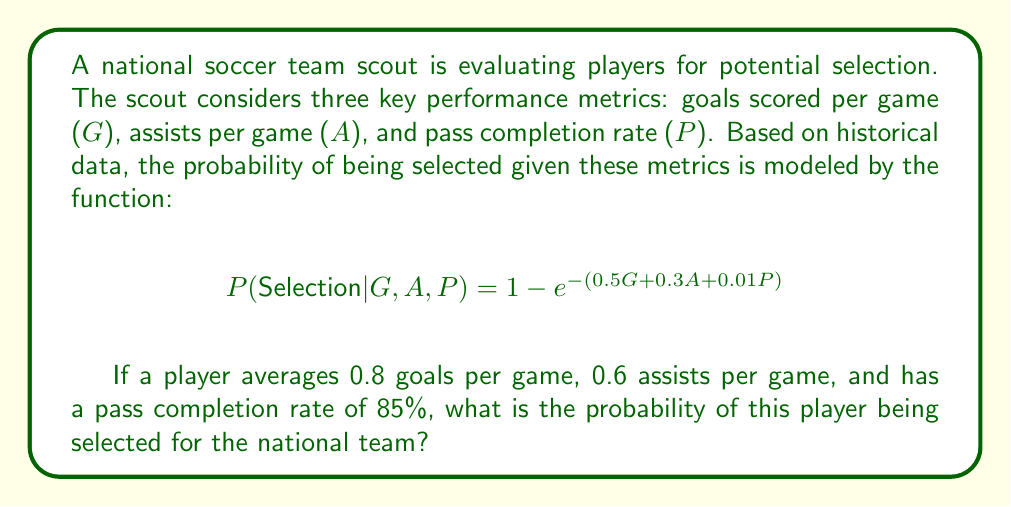Give your solution to this math problem. To solve this problem, we need to follow these steps:

1. Identify the given values:
   - Goals per game (G) = 0.8
   - Assists per game (A) = 0.6
   - Pass completion rate (P) = 85%

2. Substitute these values into the given probability function:

   $$P(\text{Selection} | G, A, P) = 1 - e^{-(0.5G + 0.3A + 0.01P)}$$

3. Calculate the exponent:
   $0.5G + 0.3A + 0.01P = (0.5 \times 0.8) + (0.3 \times 0.6) + (0.01 \times 85)$
   $= 0.4 + 0.18 + 0.85$
   $= 1.43$

4. Now our equation looks like:
   $$P(\text{Selection}) = 1 - e^{-1.43}$$

5. Calculate $e^{-1.43}$ using a calculator or computer:
   $e^{-1.43} \approx 0.2394$

6. Subtract this value from 1:
   $1 - 0.2394 = 0.7606$

Therefore, the probability of the player being selected for the national team is approximately 0.7606 or 76.06%.
Answer: The probability of the player being selected for the national team is approximately 0.7606 or 76.06%. 